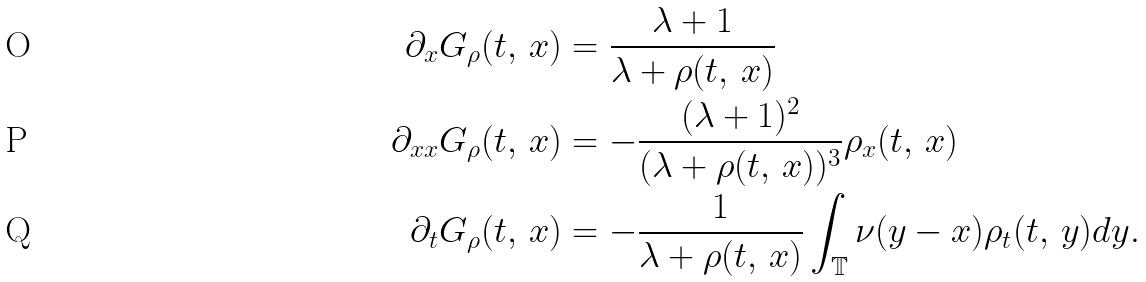<formula> <loc_0><loc_0><loc_500><loc_500>\partial _ { x } G _ { \rho } ( t , \, x ) & = \frac { \lambda + 1 } { \lambda + \rho ( t , \, x ) } \\ \partial _ { x x } G _ { \rho } ( t , \, x ) & = - \frac { ( \lambda + 1 ) ^ { 2 } } { ( \lambda + \rho ( t , \, x ) ) ^ { 3 } } \rho _ { x } ( t , \, x ) \\ \partial _ { t } G _ { \rho } ( t , \, x ) & = - \frac { 1 } { \lambda + \rho ( t , \, x ) } \int _ { \mathbb { T } } \nu ( y - x ) \rho _ { t } ( t , \, y ) d y .</formula> 